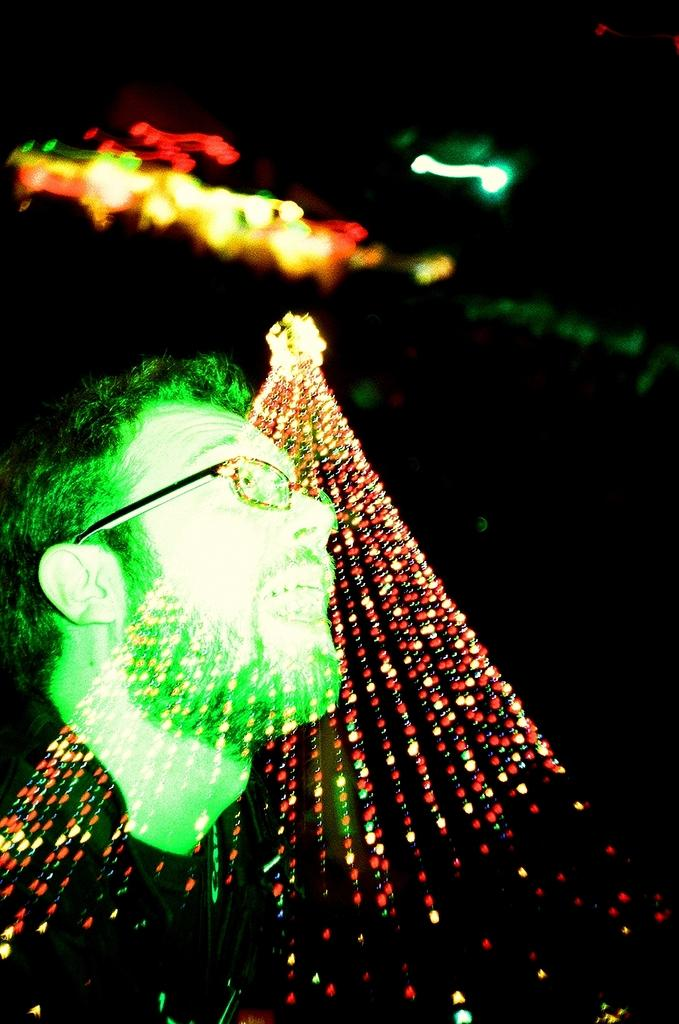What is the person in the image wearing? The person in the image is wearing glasses. What can be seen in the image besides the person? There are lights visible in the image. How would you describe the background of the image? The background of the image is blurred and dark. Are there any lights in the background of the image? Yes, there are lights in the background of the image. What type of skirt is the person wearing in the image? The person in the image is not wearing a skirt; they are wearing glasses. How many parcels can be seen in the image? There are no parcels present in the image. 